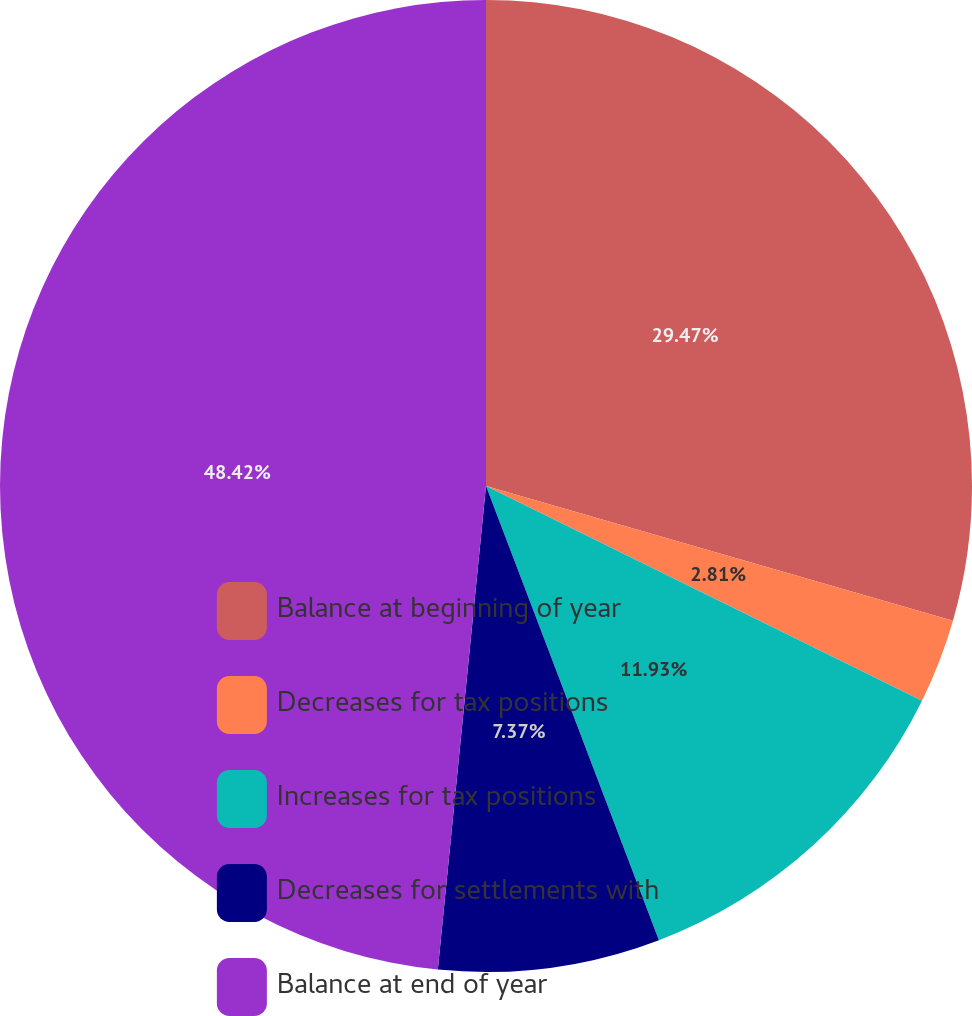<chart> <loc_0><loc_0><loc_500><loc_500><pie_chart><fcel>Balance at beginning of year<fcel>Decreases for tax positions<fcel>Increases for tax positions<fcel>Decreases for settlements with<fcel>Balance at end of year<nl><fcel>29.47%<fcel>2.81%<fcel>11.93%<fcel>7.37%<fcel>48.42%<nl></chart> 